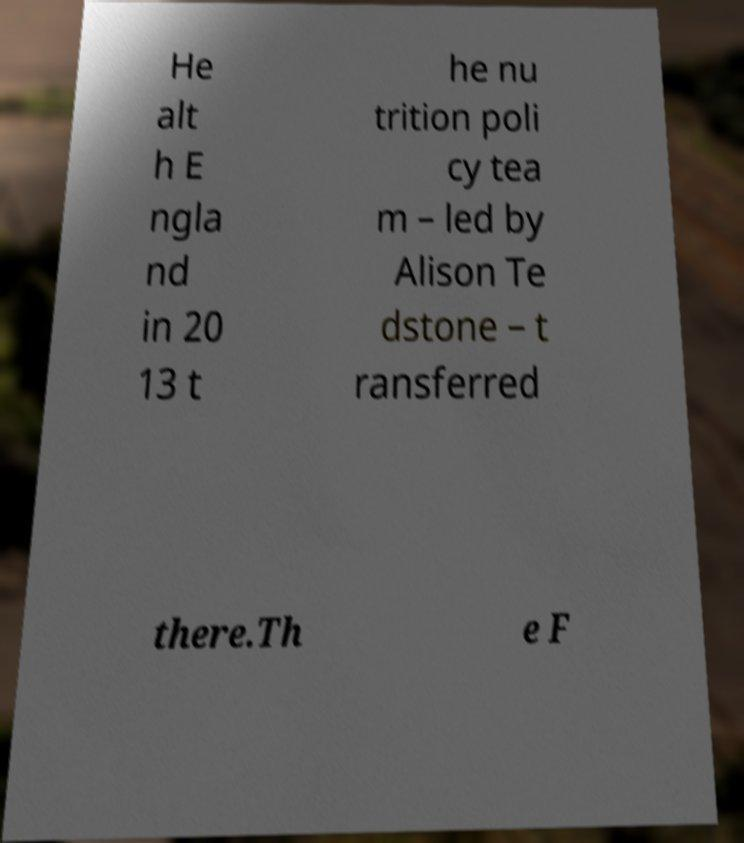There's text embedded in this image that I need extracted. Can you transcribe it verbatim? He alt h E ngla nd in 20 13 t he nu trition poli cy tea m – led by Alison Te dstone – t ransferred there.Th e F 